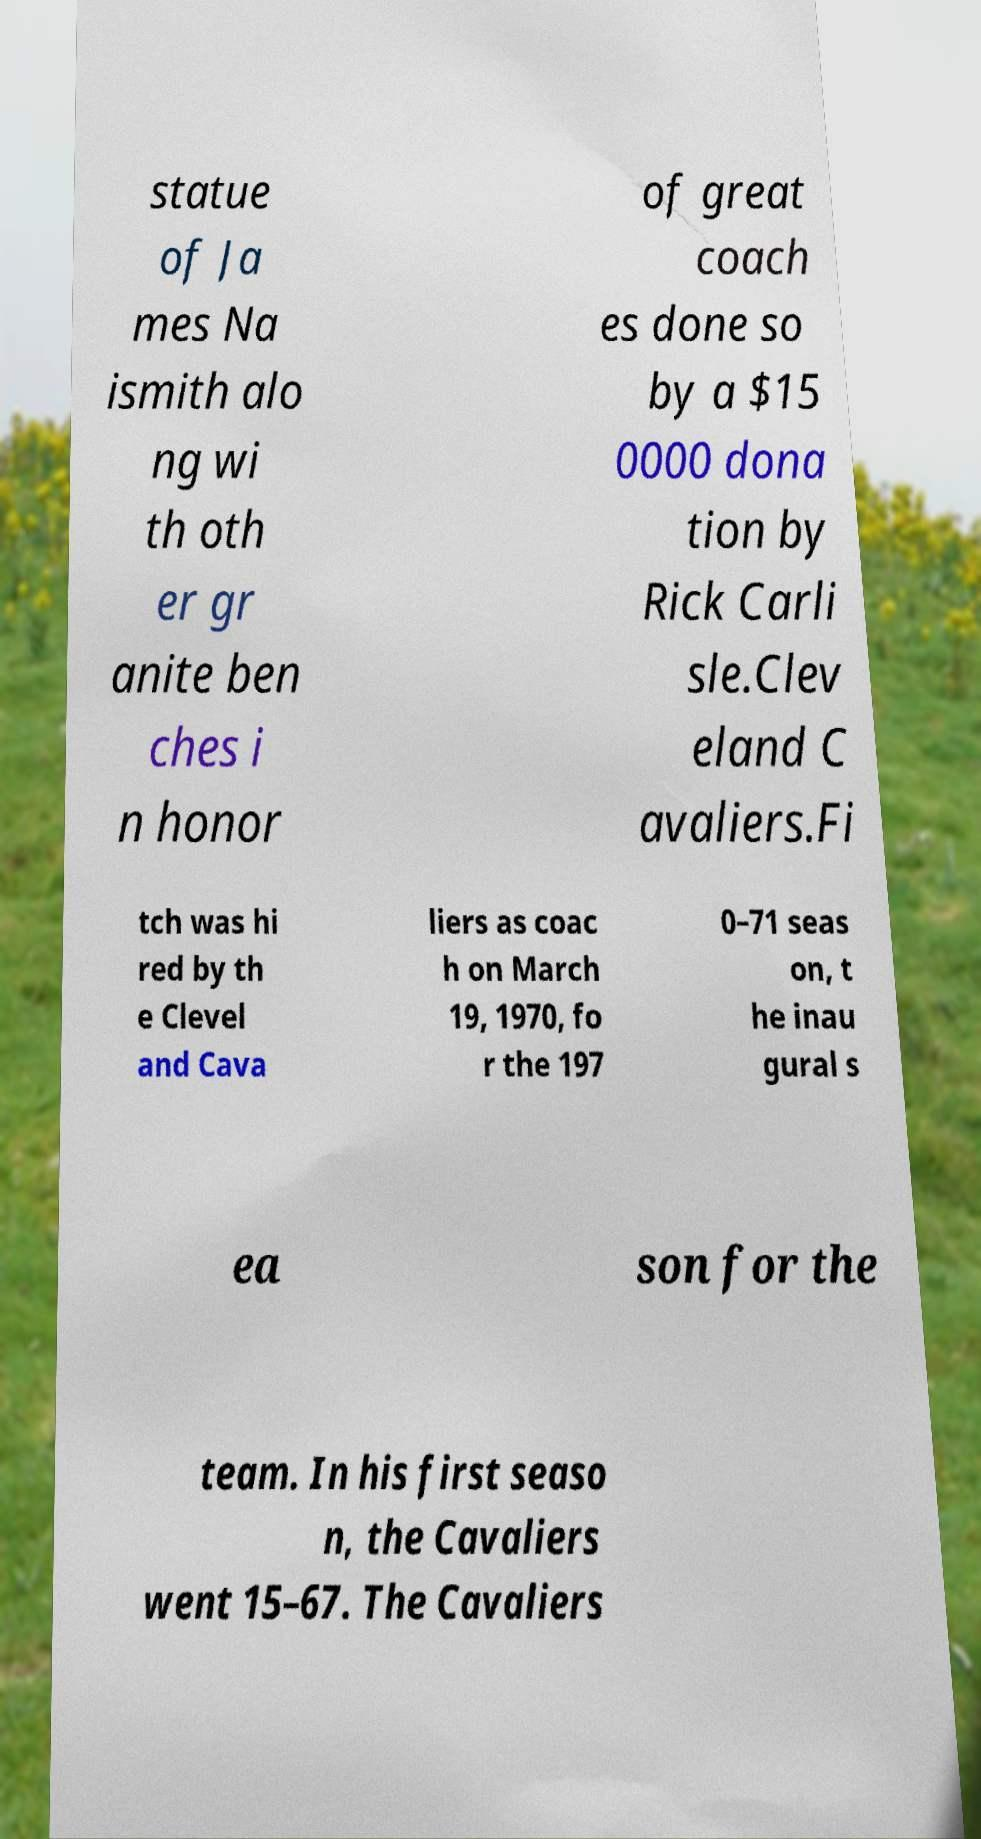I need the written content from this picture converted into text. Can you do that? statue of Ja mes Na ismith alo ng wi th oth er gr anite ben ches i n honor of great coach es done so by a $15 0000 dona tion by Rick Carli sle.Clev eland C avaliers.Fi tch was hi red by th e Clevel and Cava liers as coac h on March 19, 1970, fo r the 197 0–71 seas on, t he inau gural s ea son for the team. In his first seaso n, the Cavaliers went 15–67. The Cavaliers 